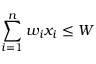Convert formula to latex. <formula><loc_0><loc_0><loc_500><loc_500>\sum _ { i = 1 } ^ { n } w _ { i } x _ { i } \leq W</formula> 